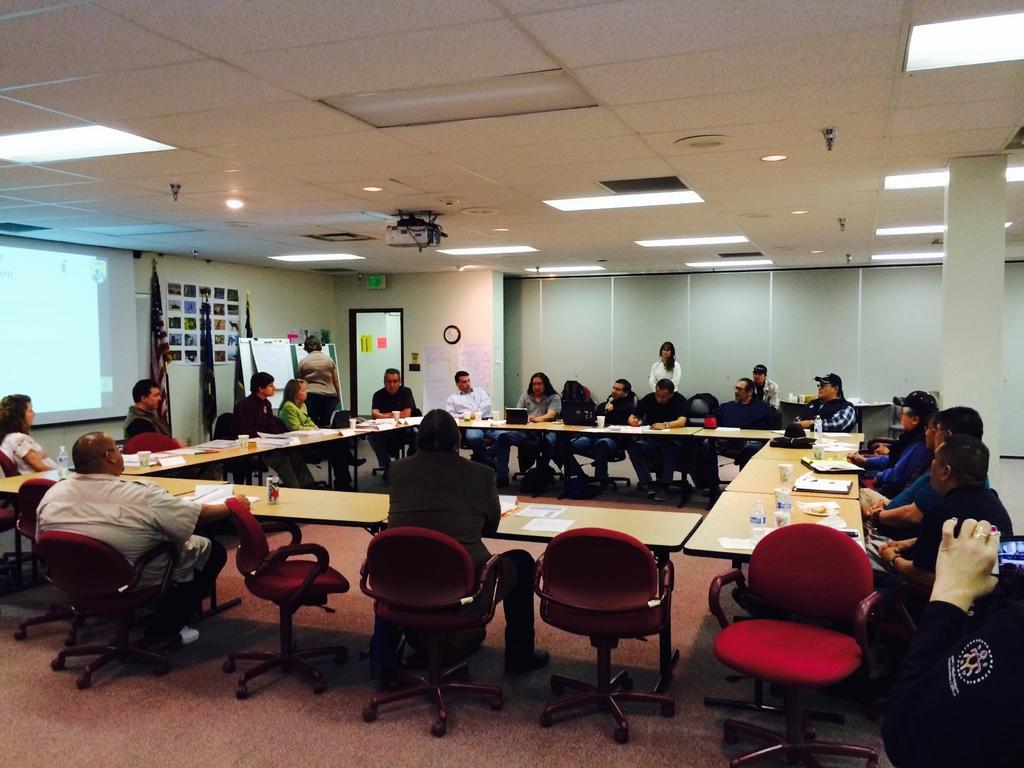Could you give a brief overview of what you see in this image? In this picture we can see some group of people sitting on the chairs in front of the table on which there are some glasses, papers and around the room there are some lights and a notice board and two flags to the left corner. 